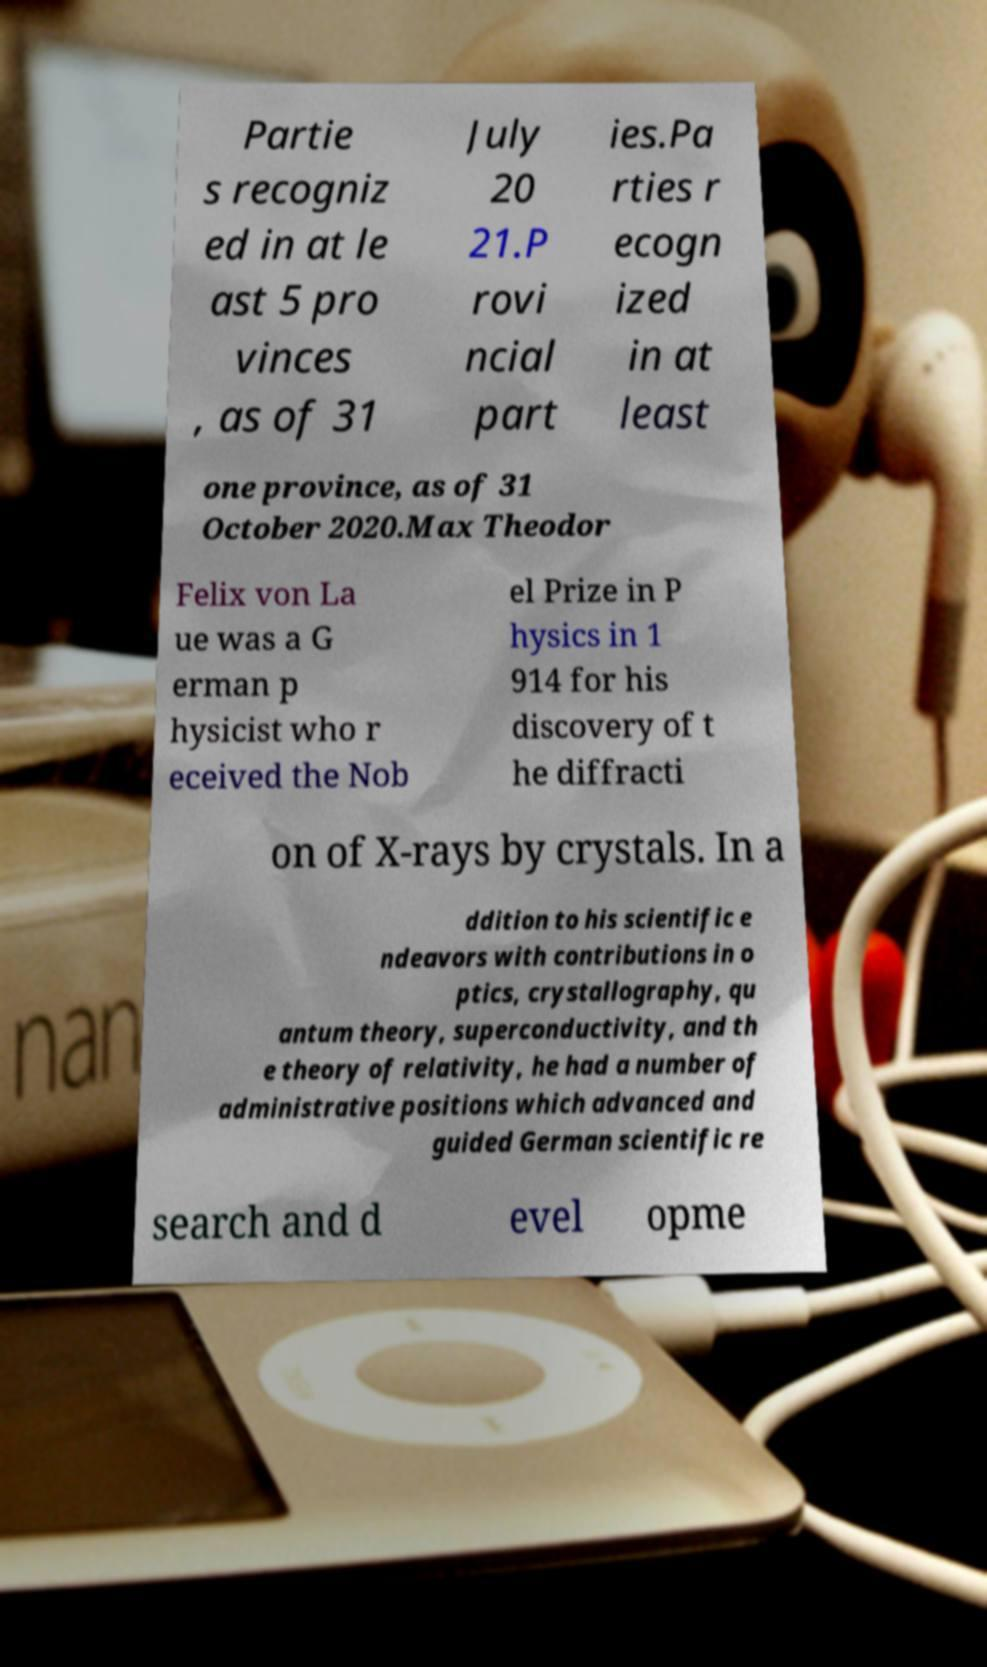For documentation purposes, I need the text within this image transcribed. Could you provide that? Partie s recogniz ed in at le ast 5 pro vinces , as of 31 July 20 21.P rovi ncial part ies.Pa rties r ecogn ized in at least one province, as of 31 October 2020.Max Theodor Felix von La ue was a G erman p hysicist who r eceived the Nob el Prize in P hysics in 1 914 for his discovery of t he diffracti on of X-rays by crystals. In a ddition to his scientific e ndeavors with contributions in o ptics, crystallography, qu antum theory, superconductivity, and th e theory of relativity, he had a number of administrative positions which advanced and guided German scientific re search and d evel opme 